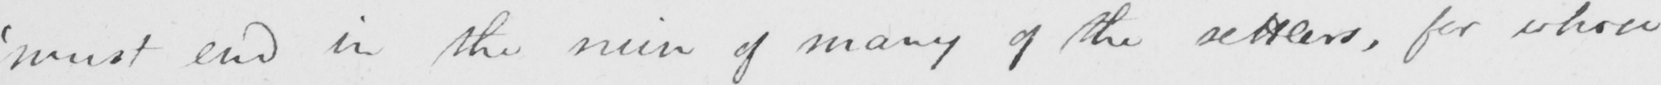Please provide the text content of this handwritten line. ' must end in the ruin of many of the settlers , for whose 